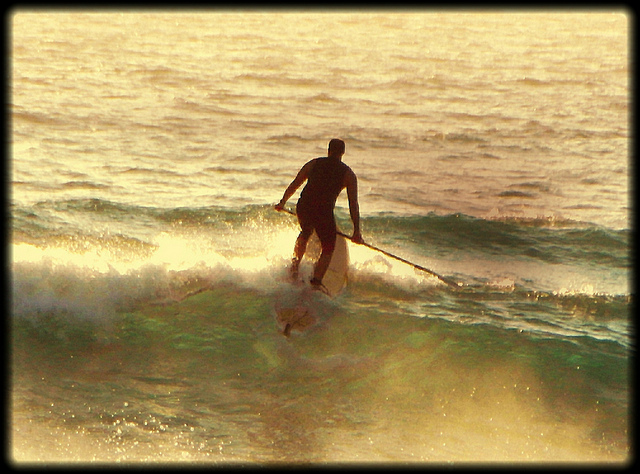Visualize the image as part of a motivational poster. What caption would you find inspiring? "Ride the Waves of Life - Balance, Focus, and Paddle On." 